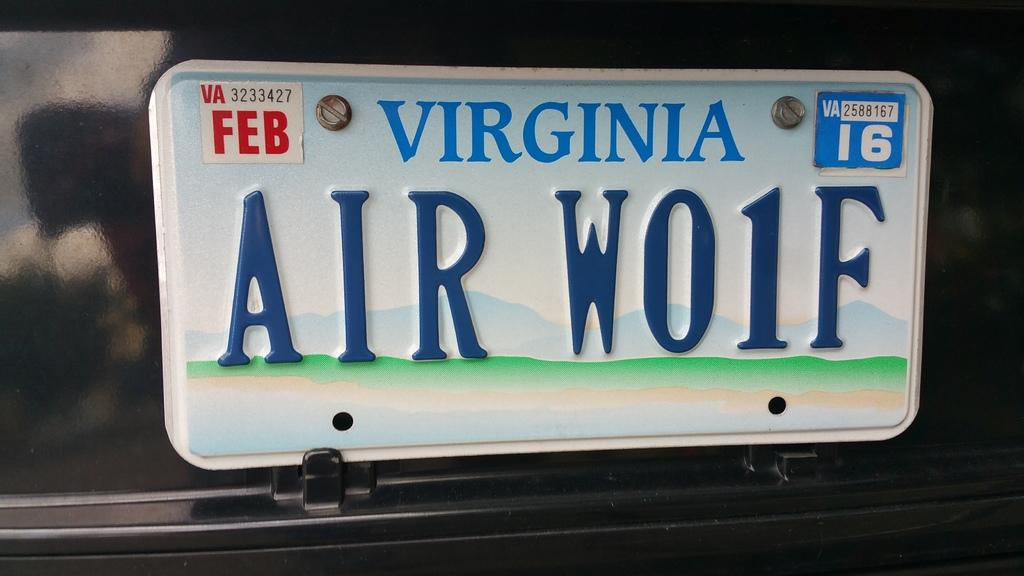<image>
Render a clear and concise summary of the photo. A Virginia license plate has the words Air wolf printed on it with a number one in place of the l in the word wolf. 